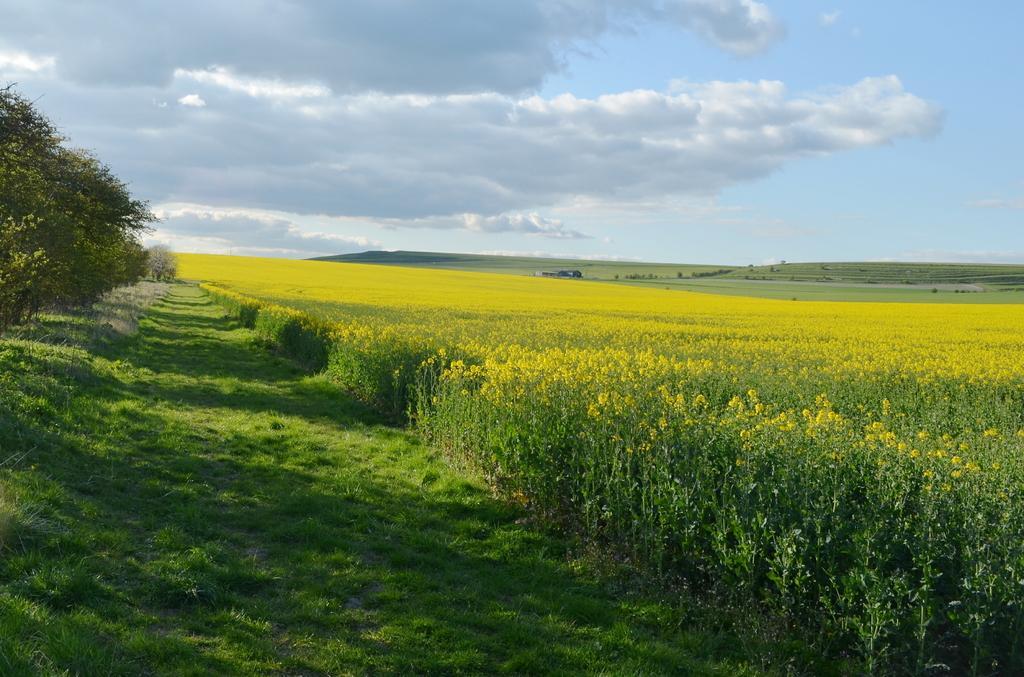Describe this image in one or two sentences. In this image we can see grass and yellow color flower field. On the left side of the image, we can see trees. In the background, we can see the land covered with grass. At the top of the image, we can see the sky with some clouds. 